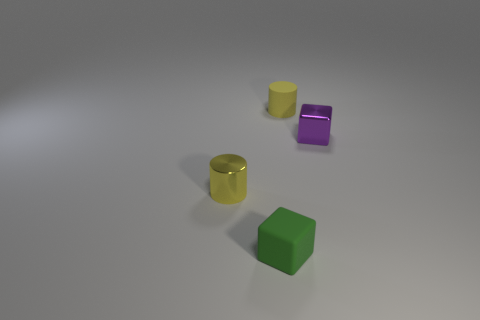There is a yellow rubber object that is the same size as the green object; what shape is it?
Offer a terse response. Cylinder. What shape is the metal object on the left side of the green matte thing?
Your answer should be very brief. Cylinder. Is the number of small green objects to the left of the green matte cube less than the number of yellow things that are to the left of the yellow matte cylinder?
Give a very brief answer. Yes. What number of purple things have the same size as the matte cylinder?
Your response must be concise. 1. What is the color of the thing that is the same material as the green cube?
Your answer should be compact. Yellow. Is the number of large blue cubes greater than the number of yellow rubber objects?
Offer a very short reply. No. There is a object that is the same material as the tiny green cube; what shape is it?
Provide a succinct answer. Cylinder. Is the number of things less than the number of tiny metallic cubes?
Offer a terse response. No. What is the small object that is both left of the purple block and behind the yellow metallic cylinder made of?
Ensure brevity in your answer.  Rubber. There is a yellow cylinder that is to the left of the green matte thing that is in front of the small yellow cylinder that is on the right side of the tiny yellow metallic thing; what size is it?
Your response must be concise. Small. 